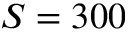<formula> <loc_0><loc_0><loc_500><loc_500>S = 3 0 0</formula> 